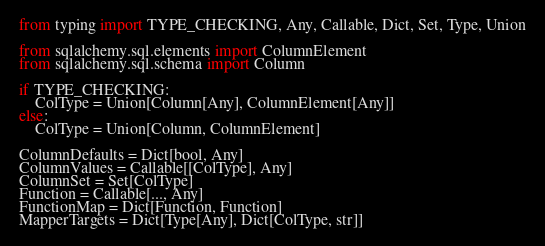Convert code to text. <code><loc_0><loc_0><loc_500><loc_500><_Python_>from typing import TYPE_CHECKING, Any, Callable, Dict, Set, Type, Union

from sqlalchemy.sql.elements import ColumnElement
from sqlalchemy.sql.schema import Column

if TYPE_CHECKING:
    ColType = Union[Column[Any], ColumnElement[Any]]
else:
    ColType = Union[Column, ColumnElement]

ColumnDefaults = Dict[bool, Any]
ColumnValues = Callable[[ColType], Any]
ColumnSet = Set[ColType]
Function = Callable[..., Any]
FunctionMap = Dict[Function, Function]
MapperTargets = Dict[Type[Any], Dict[ColType, str]]
</code> 